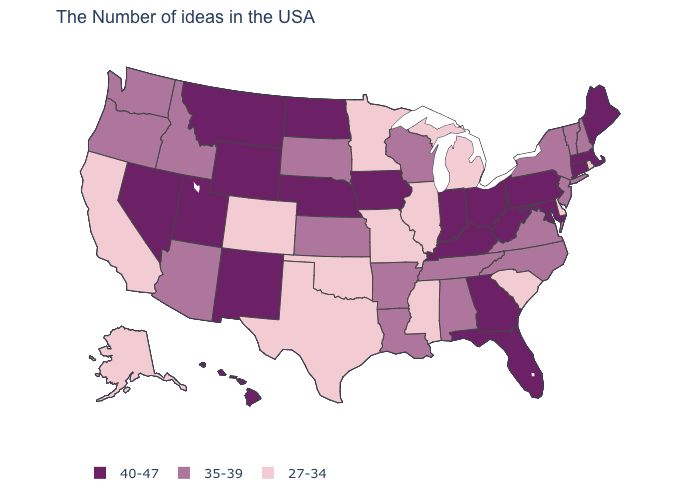What is the highest value in the MidWest ?
Write a very short answer. 40-47. How many symbols are there in the legend?
Quick response, please. 3. What is the highest value in the USA?
Answer briefly. 40-47. Name the states that have a value in the range 40-47?
Write a very short answer. Maine, Massachusetts, Connecticut, Maryland, Pennsylvania, West Virginia, Ohio, Florida, Georgia, Kentucky, Indiana, Iowa, Nebraska, North Dakota, Wyoming, New Mexico, Utah, Montana, Nevada, Hawaii. Which states have the lowest value in the MidWest?
Give a very brief answer. Michigan, Illinois, Missouri, Minnesota. Among the states that border Michigan , which have the lowest value?
Concise answer only. Wisconsin. Which states have the lowest value in the USA?
Keep it brief. Rhode Island, Delaware, South Carolina, Michigan, Illinois, Mississippi, Missouri, Minnesota, Oklahoma, Texas, Colorado, California, Alaska. Which states have the lowest value in the Northeast?
Give a very brief answer. Rhode Island. Name the states that have a value in the range 35-39?
Be succinct. New Hampshire, Vermont, New York, New Jersey, Virginia, North Carolina, Alabama, Tennessee, Wisconsin, Louisiana, Arkansas, Kansas, South Dakota, Arizona, Idaho, Washington, Oregon. What is the lowest value in the Northeast?
Keep it brief. 27-34. Does the map have missing data?
Give a very brief answer. No. Name the states that have a value in the range 40-47?
Keep it brief. Maine, Massachusetts, Connecticut, Maryland, Pennsylvania, West Virginia, Ohio, Florida, Georgia, Kentucky, Indiana, Iowa, Nebraska, North Dakota, Wyoming, New Mexico, Utah, Montana, Nevada, Hawaii. What is the value of Massachusetts?
Give a very brief answer. 40-47. Name the states that have a value in the range 40-47?
Keep it brief. Maine, Massachusetts, Connecticut, Maryland, Pennsylvania, West Virginia, Ohio, Florida, Georgia, Kentucky, Indiana, Iowa, Nebraska, North Dakota, Wyoming, New Mexico, Utah, Montana, Nevada, Hawaii. 